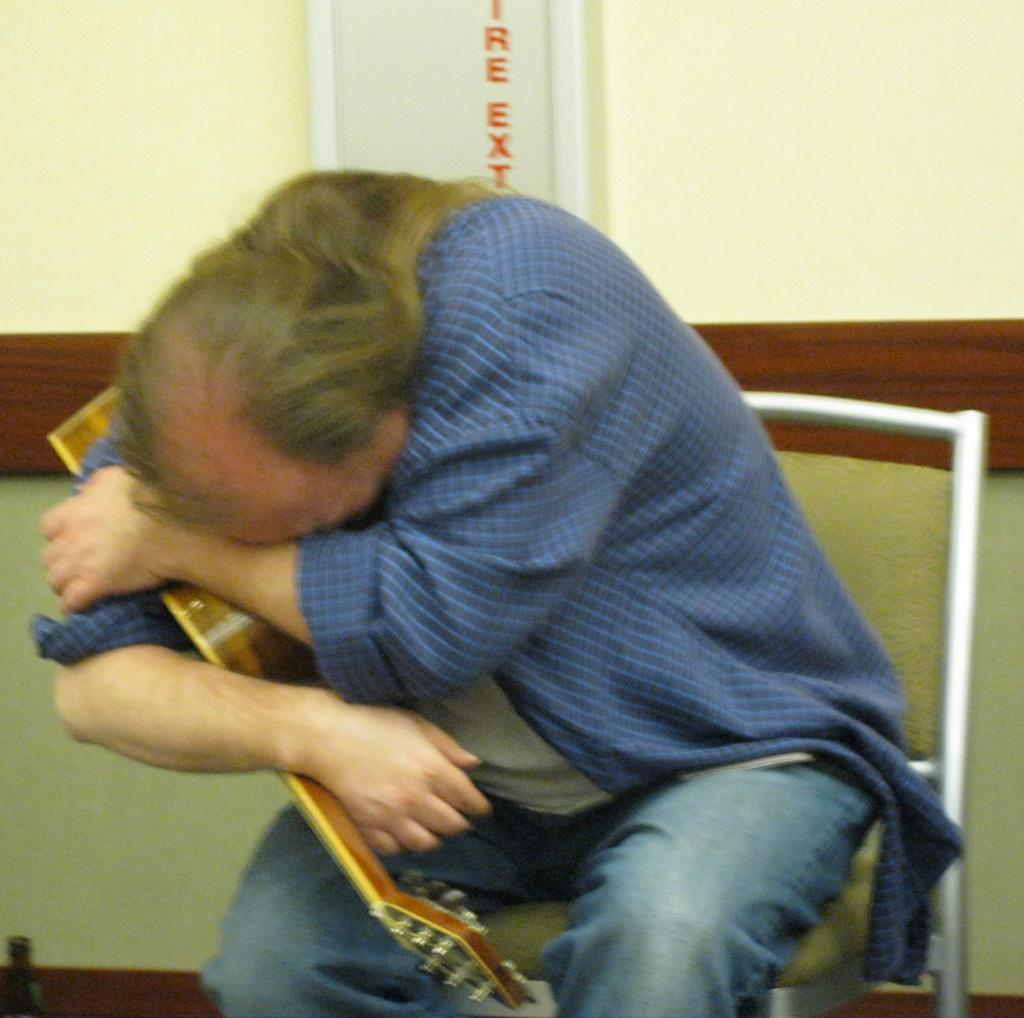What is the man in the image holding? The man is holding a guitar. How is the man holding the guitar? The man is holding the guitar tightly. How many snakes are wrapped around the man's guitar in the image? There are no snakes present in the image; the man is simply holding a guitar. 